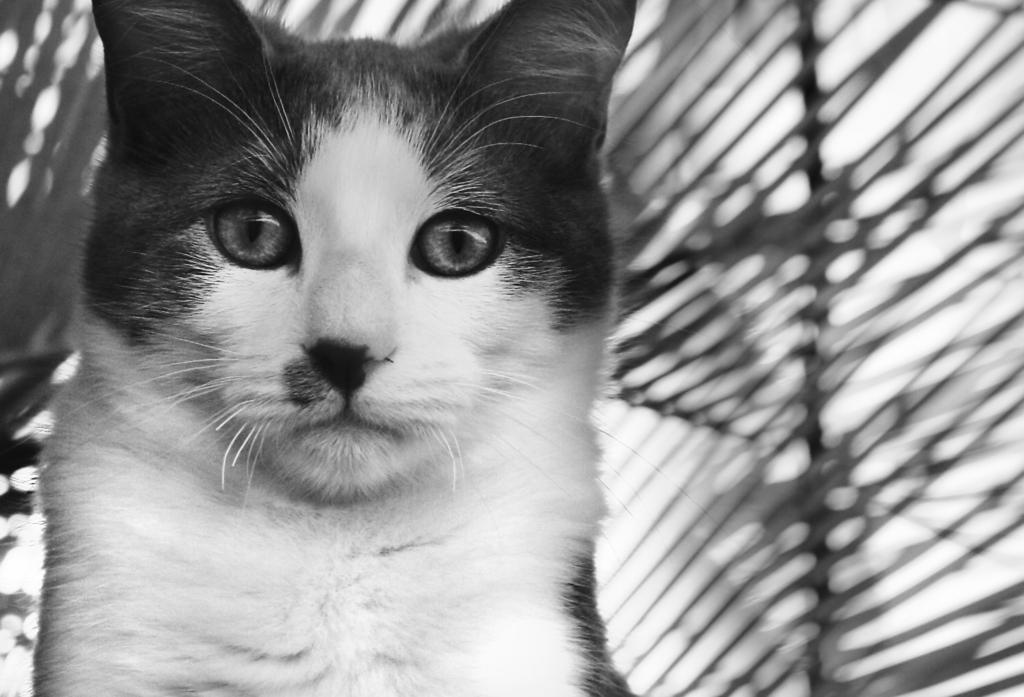What type of animal is in the image? There is a cat in the image. Where is the cat positioned in relation to the image? The cat is in front of the image. What type of structure is visible in the image? There is a metal roof top in the image. How is the metal roof top positioned in relation to the cat? The metal roof top is behind the cat. What type of trade is being conducted in the image? There is no indication of any trade being conducted in the image. What type of breakfast or lunchroom can be seen in the image? There is no breakfast or lunchroom present in the image. 